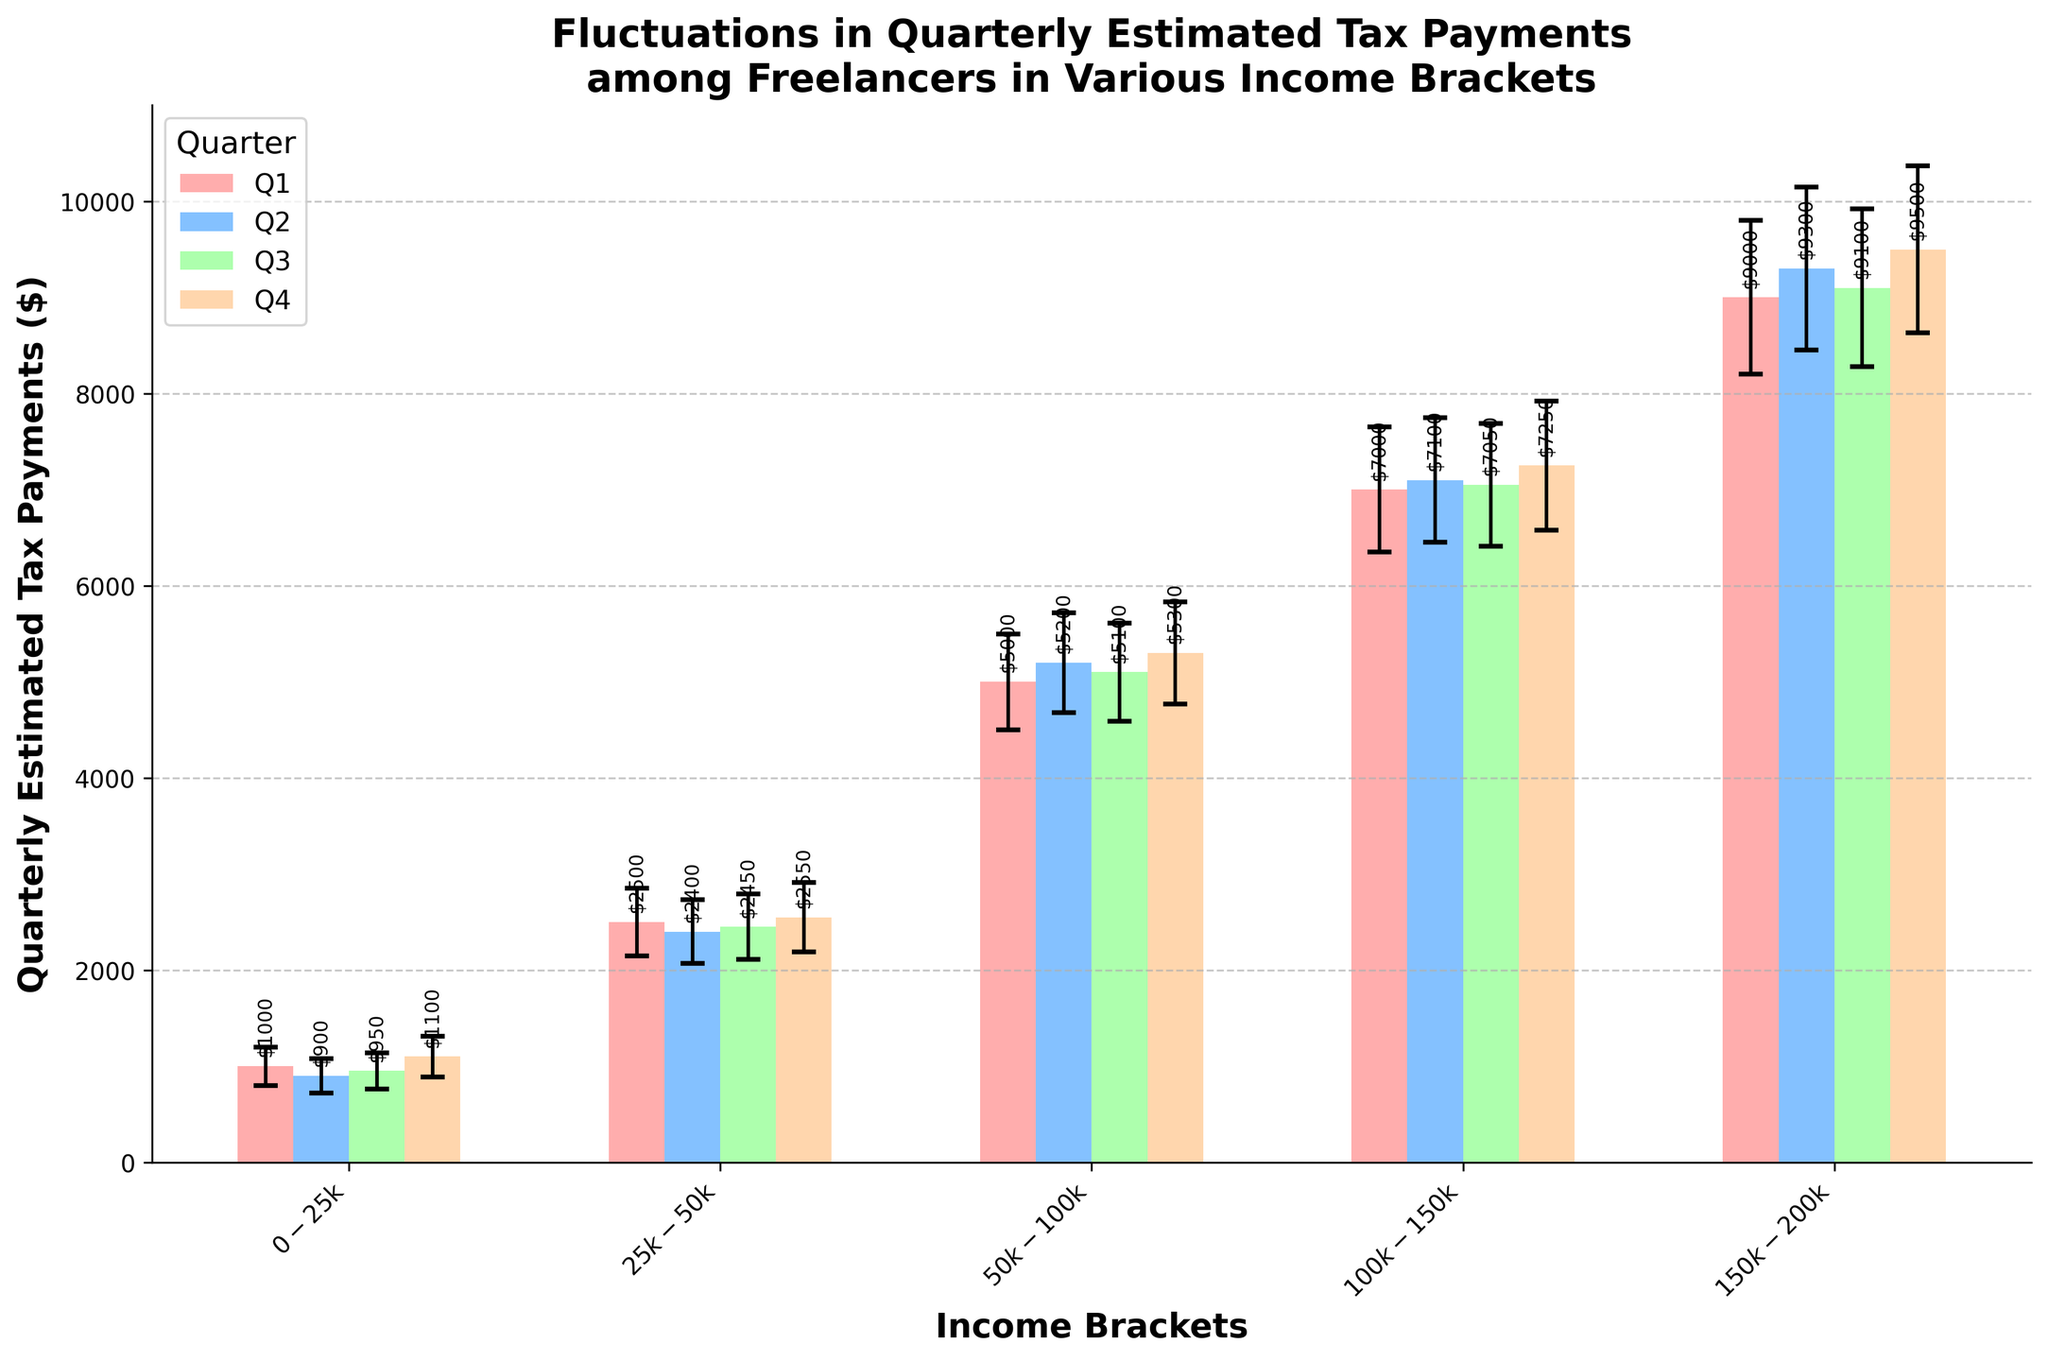What is the title of the figure? The title of the figure is typically located at the top of the plot. Here, it is "Fluctuations in Quarterly Estimated Tax Payments among Freelancers in Various Income Brackets".
Answer: Fluctuations in Quarterly Estimated Tax Payments among Freelancers in Various Income Brackets What does the y-axis represent? The y-axis typically indicates the value being measured. In this plot, the y-axis label is "Quarterly Estimated Tax Payments ($)", representing the amount of estimated tax payments in dollars.
Answer: Quarterly Estimated Tax Payments ($) Which quarter has the highest estimated tax payment for the $50k-$100k income bracket? Referring to the bars associated with the $50k-$100k income bracket, we can see that in Q4, the mean payment reaches the highest value of $5300.
Answer: Q4 What is the mean payment and standard deviation for the $0-$25k income bracket in Q1? By examining the bar for the $0-$25k income bracket in Q1 (first set of bars), we find that the mean payment is $1000 and the error bar (standard deviation) is 200.
Answer: Mean: $1000, Std Dev: $200 How does the mean quarterly payment for the $100k-$150k income bracket in Q2 compare to Q4? Look at the bars for the $100k-$150k income bracket for Q2 and Q4. The mean payments are $7100 and $7250 respectively. The mean in Q4 is slightly greater than in Q2.
Answer: Q4 > Q2 Which income bracket shows the greatest fluctuation (highest standard deviation) in Q4? To find the income bracket with the greatest fluctuation, compare the error bars in Q4. The $150k-$200k income bracket has the highest standard deviation of 870.
Answer: $150k-$200k What pattern do you observe in the estimated tax payments from Q1 to Q4 for the $25k-$50k income bracket? Analyzing the bars representing the $25k-$50k income bracket from Q1 to Q4, the mean payments are: Q1: $2500, Q2: $2400, Q3: $2450, Q4: $2550. Payments decrease slightly in Q2, then increase again up to Q4.
Answer: Decrease in Q2, then increase to Q4 Between which quarters does the $100k-$150k income bracket experience the smallest change in mean payment? Compare the mean payments across Q1 to Q4 for the $100k-$150k income bracket. The changes are Q1-Q2: 7000 to 7100 ($100), Q2-Q3: 7100 to 7050 ($50), Q3-Q4: 7050 to 7250 ($200). The smallest change is between Q2 and Q3 ($50).
Answer: Q2 to Q3 In which quarter does the $0-$25k income bracket have the lowest estimated tax payment? Check the quarterly mean payments for the $0-$25k income bracket. The values are Q1: $1000, Q2: $900, Q3: $950, Q4: $1100. The lowest is in Q2 with $900.
Answer: Q2 